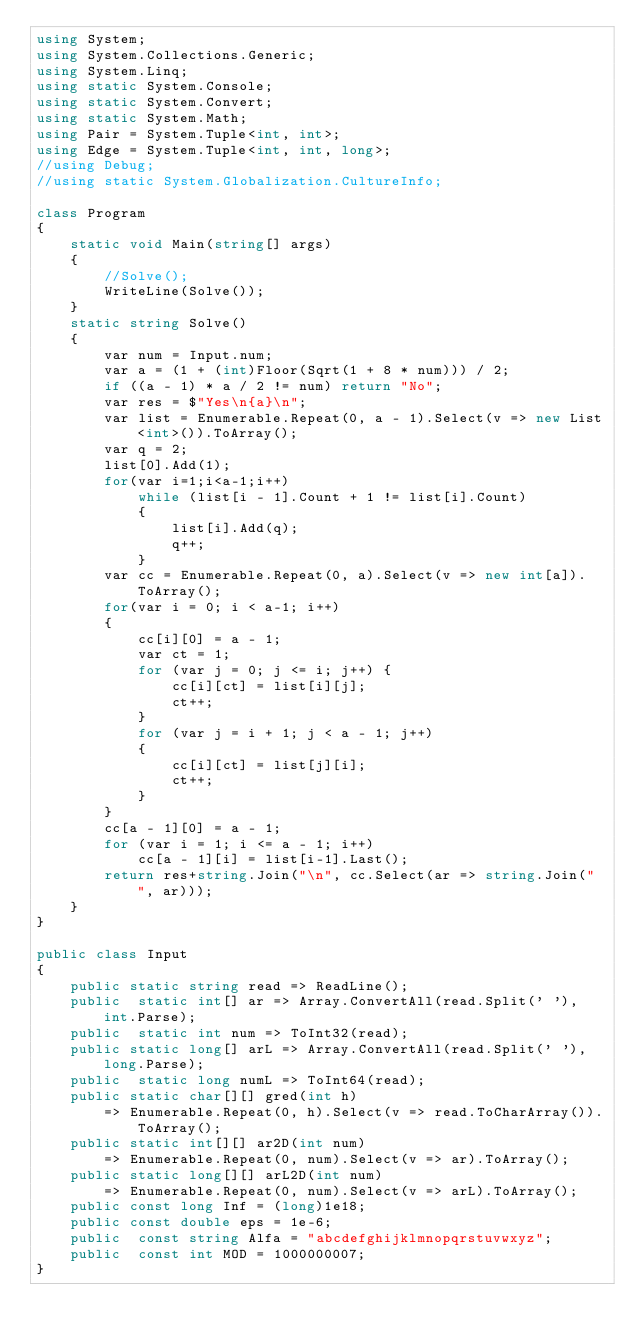Convert code to text. <code><loc_0><loc_0><loc_500><loc_500><_C#_>using System;
using System.Collections.Generic;
using System.Linq;
using static System.Console;
using static System.Convert;
using static System.Math;
using Pair = System.Tuple<int, int>;
using Edge = System.Tuple<int, int, long>;
//using Debug;
//using static System.Globalization.CultureInfo;

class Program
{
    static void Main(string[] args)
    {
        //Solve();
        WriteLine(Solve());
    }
    static string Solve()
    {
        var num = Input.num;
        var a = (1 + (int)Floor(Sqrt(1 + 8 * num))) / 2;
        if ((a - 1) * a / 2 != num) return "No";
        var res = $"Yes\n{a}\n";
        var list = Enumerable.Repeat(0, a - 1).Select(v => new List<int>()).ToArray();
        var q = 2;
        list[0].Add(1);
        for(var i=1;i<a-1;i++)
            while (list[i - 1].Count + 1 != list[i].Count)
            {
                list[i].Add(q);
                q++;
            }
        var cc = Enumerable.Repeat(0, a).Select(v => new int[a]).ToArray();
        for(var i = 0; i < a-1; i++)
        {
            cc[i][0] = a - 1;
            var ct = 1;
            for (var j = 0; j <= i; j++) {
                cc[i][ct] = list[i][j];
                ct++;
            }
            for (var j = i + 1; j < a - 1; j++)
            {
                cc[i][ct] = list[j][i];
                ct++;
            }
        }
        cc[a - 1][0] = a - 1;
        for (var i = 1; i <= a - 1; i++)
            cc[a - 1][i] = list[i-1].Last();
        return res+string.Join("\n", cc.Select(ar => string.Join(" ", ar)));
    }
}

public class Input
{
    public static string read => ReadLine();
    public  static int[] ar => Array.ConvertAll(read.Split(' '), int.Parse);
    public  static int num => ToInt32(read);
    public static long[] arL => Array.ConvertAll(read.Split(' '), long.Parse);
    public  static long numL => ToInt64(read);
    public static char[][] gred(int h) 
        => Enumerable.Repeat(0, h).Select(v => read.ToCharArray()).ToArray();
    public static int[][] ar2D(int num)
        => Enumerable.Repeat(0, num).Select(v => ar).ToArray();
    public static long[][] arL2D(int num)
        => Enumerable.Repeat(0, num).Select(v => arL).ToArray();
    public const long Inf = (long)1e18;
    public const double eps = 1e-6;
    public  const string Alfa = "abcdefghijklmnopqrstuvwxyz";
    public  const int MOD = 1000000007;
}
</code> 